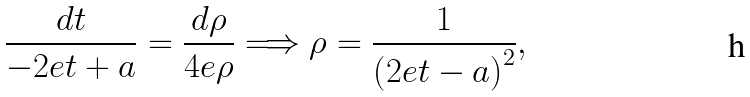<formula> <loc_0><loc_0><loc_500><loc_500>\frac { d t } { - 2 e t + a } = \frac { d \rho } { 4 e \rho } \Longrightarrow \rho = \frac { 1 } { \left ( 2 e t - a \right ) ^ { 2 } } ,</formula> 